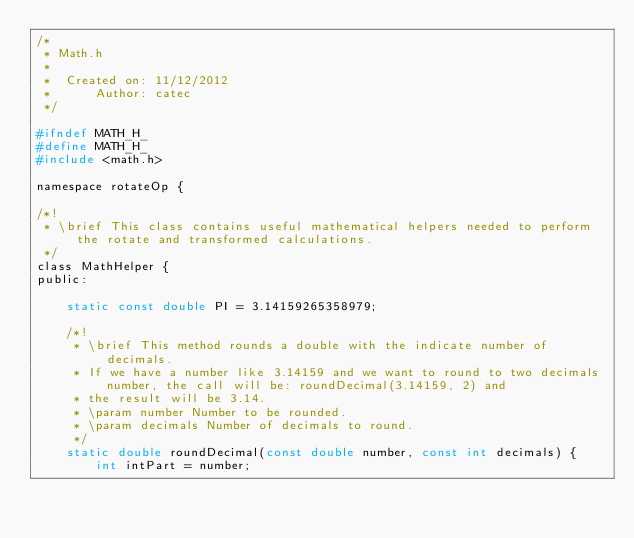<code> <loc_0><loc_0><loc_500><loc_500><_C_>/*
 * Math.h
 *
 *  Created on: 11/12/2012
 *      Author: catec
 */

#ifndef MATH_H_
#define MATH_H_
#include <math.h>

namespace rotateOp {

/*!
 * \brief This class contains useful mathematical helpers needed to perform the rotate and transformed calculations.
 */
class MathHelper {
public:

	static const double PI = 3.14159265358979;

	/*!
	 * \brief This method rounds a double with the indicate number of decimals.
	 * If we have a number like 3.14159 and we want to round to two decimals number, the call will be: roundDecimal(3.14159, 2) and
	 * the result will be 3.14.
	 * \param number Number to be rounded.
	 * \param decimals Number of decimals to round.
	 */
	static double roundDecimal(const double number, const int decimals) {
		int intPart = number;</code> 